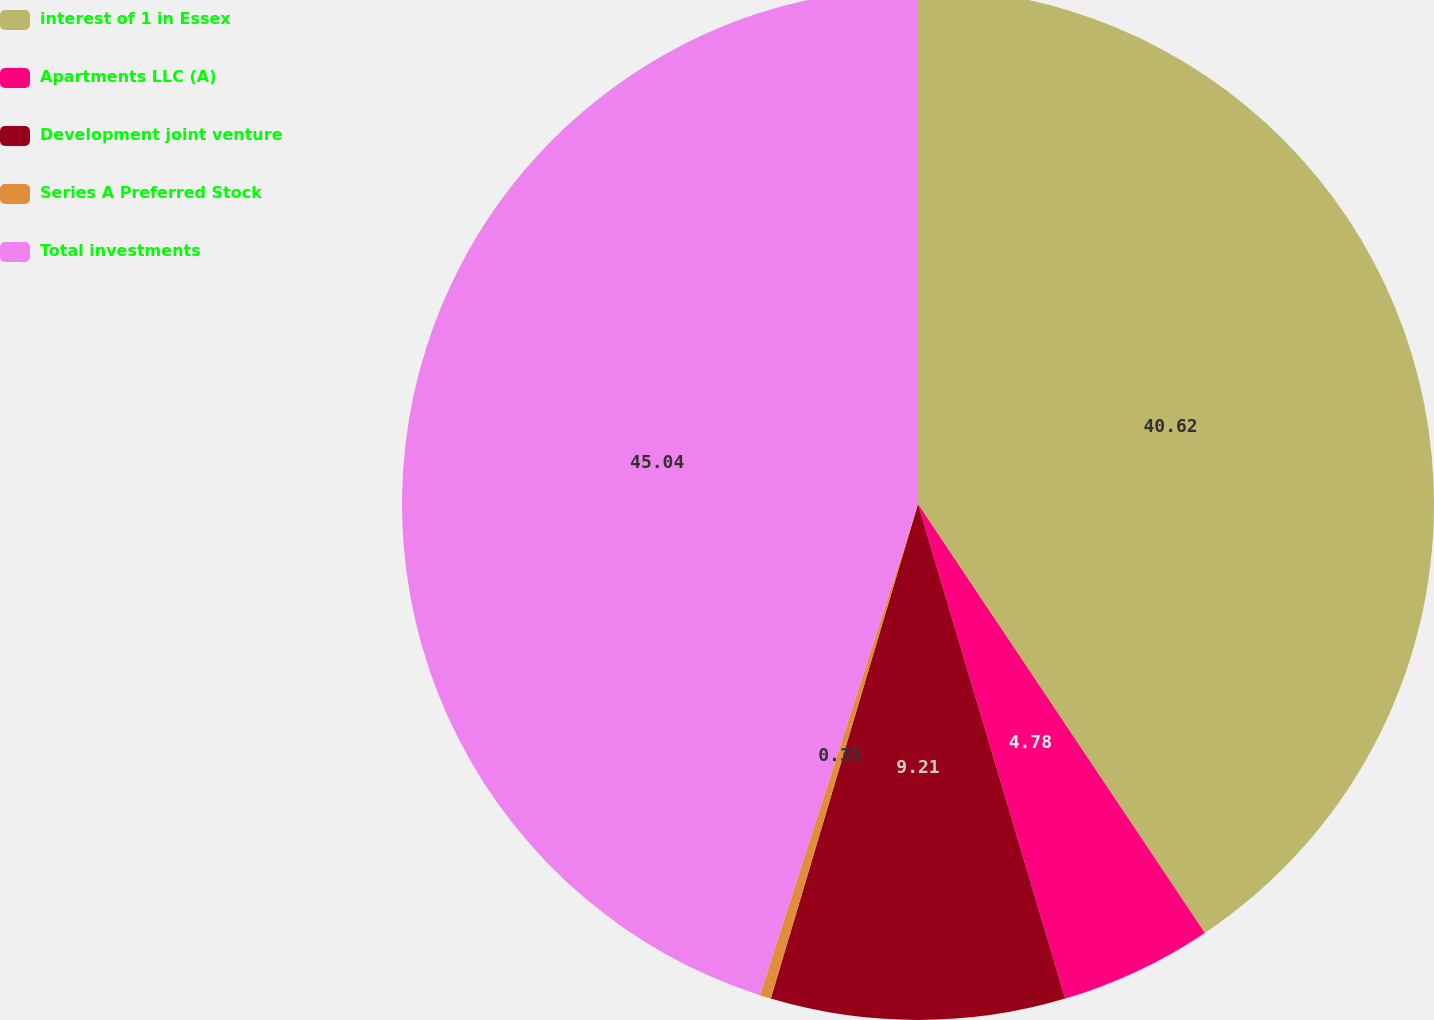Convert chart to OTSL. <chart><loc_0><loc_0><loc_500><loc_500><pie_chart><fcel>interest of 1 in Essex<fcel>Apartments LLC (A)<fcel>Development joint venture<fcel>Series A Preferred Stock<fcel>Total investments<nl><fcel>40.62%<fcel>4.78%<fcel>9.21%<fcel>0.35%<fcel>45.05%<nl></chart> 